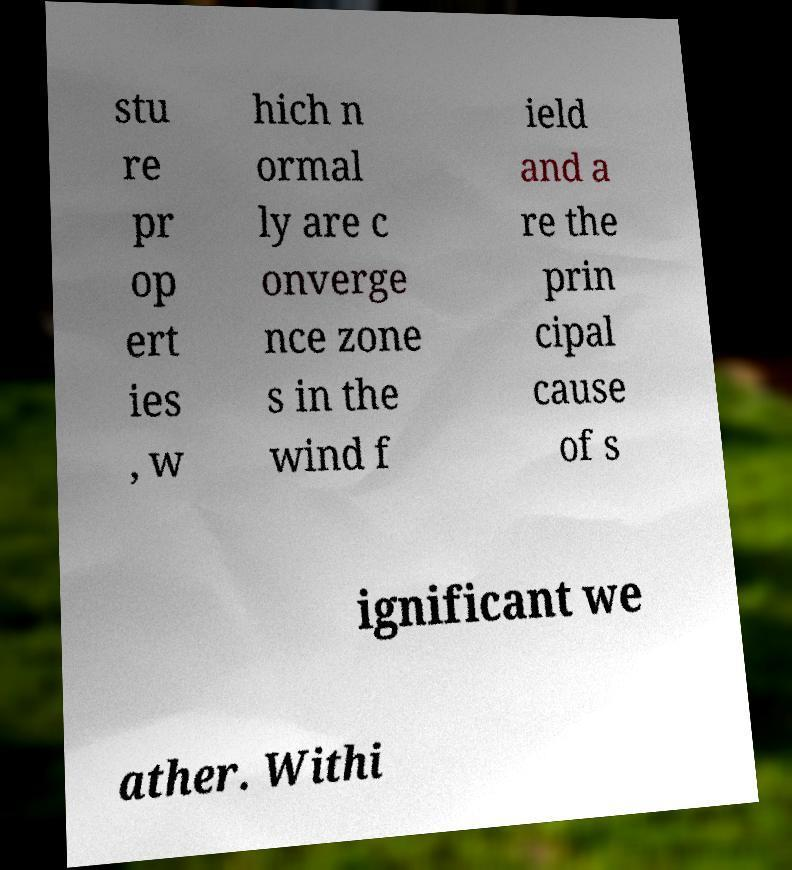Please identify and transcribe the text found in this image. stu re pr op ert ies , w hich n ormal ly are c onverge nce zone s in the wind f ield and a re the prin cipal cause of s ignificant we ather. Withi 